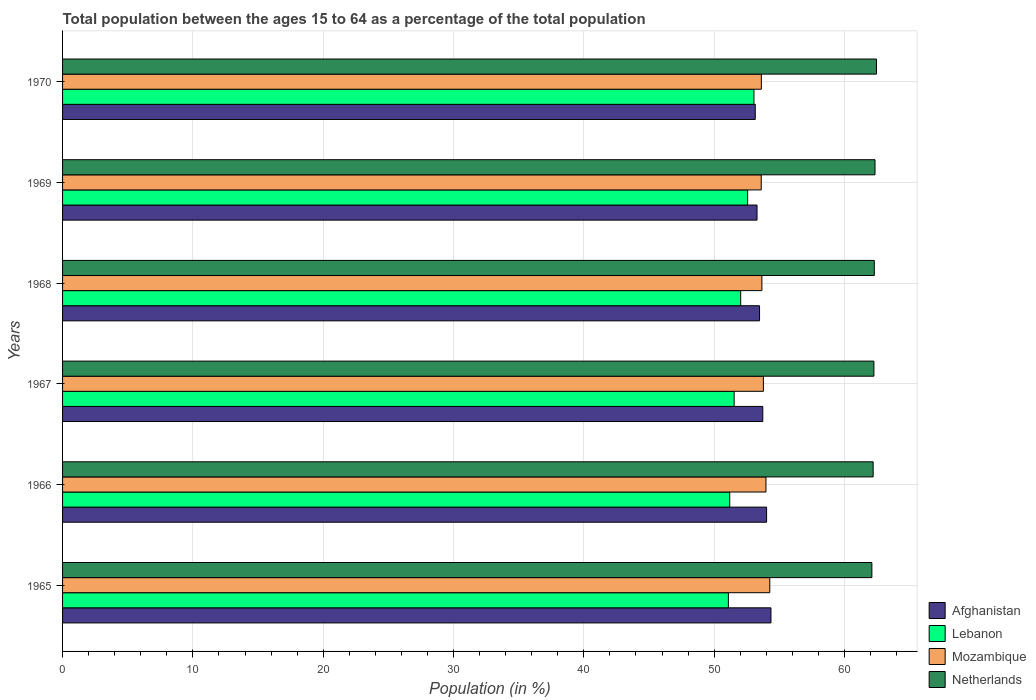How many different coloured bars are there?
Your answer should be very brief. 4. How many groups of bars are there?
Make the answer very short. 6. How many bars are there on the 3rd tick from the bottom?
Provide a short and direct response. 4. What is the label of the 1st group of bars from the top?
Provide a short and direct response. 1970. What is the percentage of the population ages 15 to 64 in Lebanon in 1965?
Give a very brief answer. 51.09. Across all years, what is the maximum percentage of the population ages 15 to 64 in Lebanon?
Provide a succinct answer. 53.06. Across all years, what is the minimum percentage of the population ages 15 to 64 in Mozambique?
Offer a terse response. 53.61. In which year was the percentage of the population ages 15 to 64 in Netherlands maximum?
Offer a terse response. 1970. In which year was the percentage of the population ages 15 to 64 in Lebanon minimum?
Provide a succinct answer. 1965. What is the total percentage of the population ages 15 to 64 in Mozambique in the graph?
Your response must be concise. 322.92. What is the difference between the percentage of the population ages 15 to 64 in Lebanon in 1966 and that in 1967?
Make the answer very short. -0.34. What is the difference between the percentage of the population ages 15 to 64 in Afghanistan in 1967 and the percentage of the population ages 15 to 64 in Netherlands in 1968?
Keep it short and to the point. -8.56. What is the average percentage of the population ages 15 to 64 in Lebanon per year?
Offer a very short reply. 51.91. In the year 1970, what is the difference between the percentage of the population ages 15 to 64 in Lebanon and percentage of the population ages 15 to 64 in Afghanistan?
Give a very brief answer. -0.1. What is the ratio of the percentage of the population ages 15 to 64 in Lebanon in 1969 to that in 1970?
Provide a short and direct response. 0.99. Is the percentage of the population ages 15 to 64 in Mozambique in 1966 less than that in 1967?
Keep it short and to the point. No. What is the difference between the highest and the second highest percentage of the population ages 15 to 64 in Afghanistan?
Your answer should be very brief. 0.33. What is the difference between the highest and the lowest percentage of the population ages 15 to 64 in Afghanistan?
Keep it short and to the point. 1.2. What does the 2nd bar from the top in 1969 represents?
Provide a short and direct response. Mozambique. What does the 1st bar from the bottom in 1968 represents?
Make the answer very short. Afghanistan. Is it the case that in every year, the sum of the percentage of the population ages 15 to 64 in Netherlands and percentage of the population ages 15 to 64 in Lebanon is greater than the percentage of the population ages 15 to 64 in Afghanistan?
Ensure brevity in your answer.  Yes. Does the graph contain any zero values?
Provide a short and direct response. No. Does the graph contain grids?
Keep it short and to the point. Yes. How many legend labels are there?
Keep it short and to the point. 4. How are the legend labels stacked?
Keep it short and to the point. Vertical. What is the title of the graph?
Provide a succinct answer. Total population between the ages 15 to 64 as a percentage of the total population. Does "Yemen, Rep." appear as one of the legend labels in the graph?
Your answer should be very brief. No. What is the label or title of the X-axis?
Ensure brevity in your answer.  Population (in %). What is the Population (in %) in Afghanistan in 1965?
Make the answer very short. 54.36. What is the Population (in %) in Lebanon in 1965?
Offer a very short reply. 51.09. What is the Population (in %) of Mozambique in 1965?
Provide a short and direct response. 54.27. What is the Population (in %) in Netherlands in 1965?
Your answer should be very brief. 62.1. What is the Population (in %) of Afghanistan in 1966?
Your answer should be compact. 54.03. What is the Population (in %) of Lebanon in 1966?
Your answer should be very brief. 51.2. What is the Population (in %) of Mozambique in 1966?
Make the answer very short. 53.98. What is the Population (in %) in Netherlands in 1966?
Give a very brief answer. 62.2. What is the Population (in %) in Afghanistan in 1967?
Your answer should be compact. 53.73. What is the Population (in %) of Lebanon in 1967?
Your answer should be very brief. 51.53. What is the Population (in %) of Mozambique in 1967?
Offer a very short reply. 53.78. What is the Population (in %) of Netherlands in 1967?
Provide a short and direct response. 62.26. What is the Population (in %) of Afghanistan in 1968?
Provide a short and direct response. 53.48. What is the Population (in %) of Lebanon in 1968?
Your response must be concise. 52.04. What is the Population (in %) in Mozambique in 1968?
Provide a succinct answer. 53.66. What is the Population (in %) of Netherlands in 1968?
Provide a short and direct response. 62.29. What is the Population (in %) of Afghanistan in 1969?
Your answer should be compact. 53.29. What is the Population (in %) of Lebanon in 1969?
Give a very brief answer. 52.57. What is the Population (in %) in Mozambique in 1969?
Give a very brief answer. 53.61. What is the Population (in %) of Netherlands in 1969?
Make the answer very short. 62.34. What is the Population (in %) in Afghanistan in 1970?
Your response must be concise. 53.16. What is the Population (in %) of Lebanon in 1970?
Ensure brevity in your answer.  53.06. What is the Population (in %) of Mozambique in 1970?
Your answer should be compact. 53.62. What is the Population (in %) of Netherlands in 1970?
Offer a very short reply. 62.45. Across all years, what is the maximum Population (in %) of Afghanistan?
Provide a short and direct response. 54.36. Across all years, what is the maximum Population (in %) of Lebanon?
Ensure brevity in your answer.  53.06. Across all years, what is the maximum Population (in %) of Mozambique?
Offer a very short reply. 54.27. Across all years, what is the maximum Population (in %) of Netherlands?
Provide a short and direct response. 62.45. Across all years, what is the minimum Population (in %) of Afghanistan?
Offer a very short reply. 53.16. Across all years, what is the minimum Population (in %) of Lebanon?
Give a very brief answer. 51.09. Across all years, what is the minimum Population (in %) of Mozambique?
Offer a terse response. 53.61. Across all years, what is the minimum Population (in %) in Netherlands?
Ensure brevity in your answer.  62.1. What is the total Population (in %) of Afghanistan in the graph?
Ensure brevity in your answer.  322.05. What is the total Population (in %) in Lebanon in the graph?
Your answer should be compact. 311.48. What is the total Population (in %) of Mozambique in the graph?
Provide a short and direct response. 322.92. What is the total Population (in %) in Netherlands in the graph?
Your answer should be compact. 373.65. What is the difference between the Population (in %) of Afghanistan in 1965 and that in 1966?
Your answer should be very brief. 0.33. What is the difference between the Population (in %) in Lebanon in 1965 and that in 1966?
Your answer should be compact. -0.1. What is the difference between the Population (in %) of Mozambique in 1965 and that in 1966?
Give a very brief answer. 0.29. What is the difference between the Population (in %) in Netherlands in 1965 and that in 1966?
Offer a terse response. -0.1. What is the difference between the Population (in %) in Afghanistan in 1965 and that in 1967?
Your answer should be compact. 0.63. What is the difference between the Population (in %) in Lebanon in 1965 and that in 1967?
Your response must be concise. -0.44. What is the difference between the Population (in %) of Mozambique in 1965 and that in 1967?
Make the answer very short. 0.49. What is the difference between the Population (in %) of Netherlands in 1965 and that in 1967?
Your answer should be very brief. -0.16. What is the difference between the Population (in %) in Afghanistan in 1965 and that in 1968?
Make the answer very short. 0.87. What is the difference between the Population (in %) in Lebanon in 1965 and that in 1968?
Keep it short and to the point. -0.94. What is the difference between the Population (in %) of Mozambique in 1965 and that in 1968?
Provide a short and direct response. 0.61. What is the difference between the Population (in %) in Netherlands in 1965 and that in 1968?
Offer a very short reply. -0.19. What is the difference between the Population (in %) in Afghanistan in 1965 and that in 1969?
Ensure brevity in your answer.  1.07. What is the difference between the Population (in %) of Lebanon in 1965 and that in 1969?
Give a very brief answer. -1.48. What is the difference between the Population (in %) of Mozambique in 1965 and that in 1969?
Provide a short and direct response. 0.66. What is the difference between the Population (in %) in Netherlands in 1965 and that in 1969?
Your response must be concise. -0.24. What is the difference between the Population (in %) in Afghanistan in 1965 and that in 1970?
Ensure brevity in your answer.  1.2. What is the difference between the Population (in %) of Lebanon in 1965 and that in 1970?
Your response must be concise. -1.96. What is the difference between the Population (in %) in Mozambique in 1965 and that in 1970?
Your answer should be very brief. 0.65. What is the difference between the Population (in %) in Netherlands in 1965 and that in 1970?
Provide a succinct answer. -0.35. What is the difference between the Population (in %) of Afghanistan in 1966 and that in 1967?
Your answer should be very brief. 0.29. What is the difference between the Population (in %) in Lebanon in 1966 and that in 1967?
Your answer should be very brief. -0.34. What is the difference between the Population (in %) of Mozambique in 1966 and that in 1967?
Provide a succinct answer. 0.2. What is the difference between the Population (in %) of Netherlands in 1966 and that in 1967?
Your answer should be compact. -0.06. What is the difference between the Population (in %) of Afghanistan in 1966 and that in 1968?
Give a very brief answer. 0.54. What is the difference between the Population (in %) in Lebanon in 1966 and that in 1968?
Keep it short and to the point. -0.84. What is the difference between the Population (in %) in Mozambique in 1966 and that in 1968?
Your response must be concise. 0.31. What is the difference between the Population (in %) in Netherlands in 1966 and that in 1968?
Give a very brief answer. -0.09. What is the difference between the Population (in %) of Afghanistan in 1966 and that in 1969?
Ensure brevity in your answer.  0.73. What is the difference between the Population (in %) of Lebanon in 1966 and that in 1969?
Keep it short and to the point. -1.37. What is the difference between the Population (in %) in Mozambique in 1966 and that in 1969?
Keep it short and to the point. 0.36. What is the difference between the Population (in %) of Netherlands in 1966 and that in 1969?
Ensure brevity in your answer.  -0.14. What is the difference between the Population (in %) in Afghanistan in 1966 and that in 1970?
Keep it short and to the point. 0.87. What is the difference between the Population (in %) in Lebanon in 1966 and that in 1970?
Keep it short and to the point. -1.86. What is the difference between the Population (in %) in Mozambique in 1966 and that in 1970?
Your response must be concise. 0.35. What is the difference between the Population (in %) of Netherlands in 1966 and that in 1970?
Offer a very short reply. -0.25. What is the difference between the Population (in %) of Afghanistan in 1967 and that in 1968?
Offer a very short reply. 0.25. What is the difference between the Population (in %) in Lebanon in 1967 and that in 1968?
Your response must be concise. -0.5. What is the difference between the Population (in %) of Mozambique in 1967 and that in 1968?
Offer a very short reply. 0.12. What is the difference between the Population (in %) of Netherlands in 1967 and that in 1968?
Make the answer very short. -0.03. What is the difference between the Population (in %) of Afghanistan in 1967 and that in 1969?
Offer a terse response. 0.44. What is the difference between the Population (in %) of Lebanon in 1967 and that in 1969?
Offer a terse response. -1.04. What is the difference between the Population (in %) of Mozambique in 1967 and that in 1969?
Make the answer very short. 0.17. What is the difference between the Population (in %) of Netherlands in 1967 and that in 1969?
Keep it short and to the point. -0.08. What is the difference between the Population (in %) in Afghanistan in 1967 and that in 1970?
Give a very brief answer. 0.58. What is the difference between the Population (in %) of Lebanon in 1967 and that in 1970?
Offer a very short reply. -1.52. What is the difference between the Population (in %) in Mozambique in 1967 and that in 1970?
Offer a terse response. 0.16. What is the difference between the Population (in %) of Netherlands in 1967 and that in 1970?
Provide a succinct answer. -0.2. What is the difference between the Population (in %) of Afghanistan in 1968 and that in 1969?
Give a very brief answer. 0.19. What is the difference between the Population (in %) of Lebanon in 1968 and that in 1969?
Offer a terse response. -0.53. What is the difference between the Population (in %) of Mozambique in 1968 and that in 1969?
Your answer should be very brief. 0.05. What is the difference between the Population (in %) of Netherlands in 1968 and that in 1969?
Provide a short and direct response. -0.06. What is the difference between the Population (in %) of Afghanistan in 1968 and that in 1970?
Your answer should be compact. 0.33. What is the difference between the Population (in %) of Lebanon in 1968 and that in 1970?
Your response must be concise. -1.02. What is the difference between the Population (in %) of Mozambique in 1968 and that in 1970?
Give a very brief answer. 0.04. What is the difference between the Population (in %) in Netherlands in 1968 and that in 1970?
Provide a short and direct response. -0.17. What is the difference between the Population (in %) of Afghanistan in 1969 and that in 1970?
Your answer should be compact. 0.14. What is the difference between the Population (in %) of Lebanon in 1969 and that in 1970?
Provide a succinct answer. -0.48. What is the difference between the Population (in %) in Mozambique in 1969 and that in 1970?
Provide a short and direct response. -0.01. What is the difference between the Population (in %) in Netherlands in 1969 and that in 1970?
Give a very brief answer. -0.11. What is the difference between the Population (in %) in Afghanistan in 1965 and the Population (in %) in Lebanon in 1966?
Ensure brevity in your answer.  3.16. What is the difference between the Population (in %) of Afghanistan in 1965 and the Population (in %) of Mozambique in 1966?
Provide a short and direct response. 0.38. What is the difference between the Population (in %) in Afghanistan in 1965 and the Population (in %) in Netherlands in 1966?
Offer a very short reply. -7.84. What is the difference between the Population (in %) in Lebanon in 1965 and the Population (in %) in Mozambique in 1966?
Offer a terse response. -2.88. What is the difference between the Population (in %) of Lebanon in 1965 and the Population (in %) of Netherlands in 1966?
Provide a succinct answer. -11.11. What is the difference between the Population (in %) in Mozambique in 1965 and the Population (in %) in Netherlands in 1966?
Provide a short and direct response. -7.93. What is the difference between the Population (in %) in Afghanistan in 1965 and the Population (in %) in Lebanon in 1967?
Your response must be concise. 2.82. What is the difference between the Population (in %) of Afghanistan in 1965 and the Population (in %) of Mozambique in 1967?
Your answer should be very brief. 0.58. What is the difference between the Population (in %) of Afghanistan in 1965 and the Population (in %) of Netherlands in 1967?
Keep it short and to the point. -7.9. What is the difference between the Population (in %) in Lebanon in 1965 and the Population (in %) in Mozambique in 1967?
Offer a very short reply. -2.69. What is the difference between the Population (in %) of Lebanon in 1965 and the Population (in %) of Netherlands in 1967?
Provide a short and direct response. -11.17. What is the difference between the Population (in %) in Mozambique in 1965 and the Population (in %) in Netherlands in 1967?
Your response must be concise. -7.99. What is the difference between the Population (in %) in Afghanistan in 1965 and the Population (in %) in Lebanon in 1968?
Your answer should be very brief. 2.32. What is the difference between the Population (in %) in Afghanistan in 1965 and the Population (in %) in Mozambique in 1968?
Your answer should be compact. 0.7. What is the difference between the Population (in %) of Afghanistan in 1965 and the Population (in %) of Netherlands in 1968?
Offer a very short reply. -7.93. What is the difference between the Population (in %) of Lebanon in 1965 and the Population (in %) of Mozambique in 1968?
Ensure brevity in your answer.  -2.57. What is the difference between the Population (in %) in Lebanon in 1965 and the Population (in %) in Netherlands in 1968?
Offer a terse response. -11.2. What is the difference between the Population (in %) of Mozambique in 1965 and the Population (in %) of Netherlands in 1968?
Provide a succinct answer. -8.02. What is the difference between the Population (in %) of Afghanistan in 1965 and the Population (in %) of Lebanon in 1969?
Your response must be concise. 1.79. What is the difference between the Population (in %) of Afghanistan in 1965 and the Population (in %) of Mozambique in 1969?
Keep it short and to the point. 0.75. What is the difference between the Population (in %) of Afghanistan in 1965 and the Population (in %) of Netherlands in 1969?
Provide a short and direct response. -7.99. What is the difference between the Population (in %) in Lebanon in 1965 and the Population (in %) in Mozambique in 1969?
Provide a short and direct response. -2.52. What is the difference between the Population (in %) of Lebanon in 1965 and the Population (in %) of Netherlands in 1969?
Offer a very short reply. -11.25. What is the difference between the Population (in %) of Mozambique in 1965 and the Population (in %) of Netherlands in 1969?
Ensure brevity in your answer.  -8.07. What is the difference between the Population (in %) of Afghanistan in 1965 and the Population (in %) of Lebanon in 1970?
Keep it short and to the point. 1.3. What is the difference between the Population (in %) of Afghanistan in 1965 and the Population (in %) of Mozambique in 1970?
Offer a terse response. 0.73. What is the difference between the Population (in %) of Afghanistan in 1965 and the Population (in %) of Netherlands in 1970?
Your answer should be compact. -8.1. What is the difference between the Population (in %) in Lebanon in 1965 and the Population (in %) in Mozambique in 1970?
Ensure brevity in your answer.  -2.53. What is the difference between the Population (in %) of Lebanon in 1965 and the Population (in %) of Netherlands in 1970?
Provide a succinct answer. -11.36. What is the difference between the Population (in %) in Mozambique in 1965 and the Population (in %) in Netherlands in 1970?
Your response must be concise. -8.19. What is the difference between the Population (in %) in Afghanistan in 1966 and the Population (in %) in Lebanon in 1967?
Make the answer very short. 2.49. What is the difference between the Population (in %) of Afghanistan in 1966 and the Population (in %) of Mozambique in 1967?
Offer a terse response. 0.25. What is the difference between the Population (in %) of Afghanistan in 1966 and the Population (in %) of Netherlands in 1967?
Offer a terse response. -8.23. What is the difference between the Population (in %) in Lebanon in 1966 and the Population (in %) in Mozambique in 1967?
Give a very brief answer. -2.58. What is the difference between the Population (in %) of Lebanon in 1966 and the Population (in %) of Netherlands in 1967?
Offer a very short reply. -11.06. What is the difference between the Population (in %) of Mozambique in 1966 and the Population (in %) of Netherlands in 1967?
Offer a terse response. -8.28. What is the difference between the Population (in %) in Afghanistan in 1966 and the Population (in %) in Lebanon in 1968?
Provide a short and direct response. 1.99. What is the difference between the Population (in %) in Afghanistan in 1966 and the Population (in %) in Mozambique in 1968?
Make the answer very short. 0.36. What is the difference between the Population (in %) of Afghanistan in 1966 and the Population (in %) of Netherlands in 1968?
Give a very brief answer. -8.26. What is the difference between the Population (in %) in Lebanon in 1966 and the Population (in %) in Mozambique in 1968?
Your answer should be very brief. -2.47. What is the difference between the Population (in %) of Lebanon in 1966 and the Population (in %) of Netherlands in 1968?
Your answer should be compact. -11.09. What is the difference between the Population (in %) of Mozambique in 1966 and the Population (in %) of Netherlands in 1968?
Offer a terse response. -8.31. What is the difference between the Population (in %) of Afghanistan in 1966 and the Population (in %) of Lebanon in 1969?
Provide a short and direct response. 1.45. What is the difference between the Population (in %) of Afghanistan in 1966 and the Population (in %) of Mozambique in 1969?
Keep it short and to the point. 0.41. What is the difference between the Population (in %) of Afghanistan in 1966 and the Population (in %) of Netherlands in 1969?
Your response must be concise. -8.32. What is the difference between the Population (in %) of Lebanon in 1966 and the Population (in %) of Mozambique in 1969?
Your answer should be compact. -2.42. What is the difference between the Population (in %) in Lebanon in 1966 and the Population (in %) in Netherlands in 1969?
Provide a short and direct response. -11.15. What is the difference between the Population (in %) in Mozambique in 1966 and the Population (in %) in Netherlands in 1969?
Provide a succinct answer. -8.37. What is the difference between the Population (in %) of Afghanistan in 1966 and the Population (in %) of Lebanon in 1970?
Your answer should be very brief. 0.97. What is the difference between the Population (in %) of Afghanistan in 1966 and the Population (in %) of Mozambique in 1970?
Keep it short and to the point. 0.4. What is the difference between the Population (in %) of Afghanistan in 1966 and the Population (in %) of Netherlands in 1970?
Make the answer very short. -8.43. What is the difference between the Population (in %) in Lebanon in 1966 and the Population (in %) in Mozambique in 1970?
Give a very brief answer. -2.43. What is the difference between the Population (in %) in Lebanon in 1966 and the Population (in %) in Netherlands in 1970?
Your answer should be compact. -11.26. What is the difference between the Population (in %) in Mozambique in 1966 and the Population (in %) in Netherlands in 1970?
Your response must be concise. -8.48. What is the difference between the Population (in %) in Afghanistan in 1967 and the Population (in %) in Lebanon in 1968?
Offer a terse response. 1.7. What is the difference between the Population (in %) of Afghanistan in 1967 and the Population (in %) of Mozambique in 1968?
Your response must be concise. 0.07. What is the difference between the Population (in %) of Afghanistan in 1967 and the Population (in %) of Netherlands in 1968?
Your answer should be very brief. -8.56. What is the difference between the Population (in %) of Lebanon in 1967 and the Population (in %) of Mozambique in 1968?
Make the answer very short. -2.13. What is the difference between the Population (in %) of Lebanon in 1967 and the Population (in %) of Netherlands in 1968?
Your response must be concise. -10.75. What is the difference between the Population (in %) in Mozambique in 1967 and the Population (in %) in Netherlands in 1968?
Provide a succinct answer. -8.51. What is the difference between the Population (in %) of Afghanistan in 1967 and the Population (in %) of Lebanon in 1969?
Keep it short and to the point. 1.16. What is the difference between the Population (in %) in Afghanistan in 1967 and the Population (in %) in Mozambique in 1969?
Your answer should be very brief. 0.12. What is the difference between the Population (in %) of Afghanistan in 1967 and the Population (in %) of Netherlands in 1969?
Make the answer very short. -8.61. What is the difference between the Population (in %) in Lebanon in 1967 and the Population (in %) in Mozambique in 1969?
Your answer should be compact. -2.08. What is the difference between the Population (in %) of Lebanon in 1967 and the Population (in %) of Netherlands in 1969?
Provide a short and direct response. -10.81. What is the difference between the Population (in %) of Mozambique in 1967 and the Population (in %) of Netherlands in 1969?
Provide a short and direct response. -8.56. What is the difference between the Population (in %) in Afghanistan in 1967 and the Population (in %) in Lebanon in 1970?
Keep it short and to the point. 0.68. What is the difference between the Population (in %) of Afghanistan in 1967 and the Population (in %) of Mozambique in 1970?
Offer a terse response. 0.11. What is the difference between the Population (in %) of Afghanistan in 1967 and the Population (in %) of Netherlands in 1970?
Give a very brief answer. -8.72. What is the difference between the Population (in %) of Lebanon in 1967 and the Population (in %) of Mozambique in 1970?
Offer a very short reply. -2.09. What is the difference between the Population (in %) in Lebanon in 1967 and the Population (in %) in Netherlands in 1970?
Your response must be concise. -10.92. What is the difference between the Population (in %) of Mozambique in 1967 and the Population (in %) of Netherlands in 1970?
Keep it short and to the point. -8.68. What is the difference between the Population (in %) in Afghanistan in 1968 and the Population (in %) in Lebanon in 1969?
Make the answer very short. 0.91. What is the difference between the Population (in %) of Afghanistan in 1968 and the Population (in %) of Mozambique in 1969?
Your answer should be compact. -0.13. What is the difference between the Population (in %) in Afghanistan in 1968 and the Population (in %) in Netherlands in 1969?
Your answer should be very brief. -8.86. What is the difference between the Population (in %) in Lebanon in 1968 and the Population (in %) in Mozambique in 1969?
Keep it short and to the point. -1.58. What is the difference between the Population (in %) in Lebanon in 1968 and the Population (in %) in Netherlands in 1969?
Provide a succinct answer. -10.31. What is the difference between the Population (in %) of Mozambique in 1968 and the Population (in %) of Netherlands in 1969?
Ensure brevity in your answer.  -8.68. What is the difference between the Population (in %) in Afghanistan in 1968 and the Population (in %) in Lebanon in 1970?
Make the answer very short. 0.43. What is the difference between the Population (in %) in Afghanistan in 1968 and the Population (in %) in Mozambique in 1970?
Offer a terse response. -0.14. What is the difference between the Population (in %) of Afghanistan in 1968 and the Population (in %) of Netherlands in 1970?
Keep it short and to the point. -8.97. What is the difference between the Population (in %) in Lebanon in 1968 and the Population (in %) in Mozambique in 1970?
Ensure brevity in your answer.  -1.59. What is the difference between the Population (in %) of Lebanon in 1968 and the Population (in %) of Netherlands in 1970?
Your answer should be compact. -10.42. What is the difference between the Population (in %) in Mozambique in 1968 and the Population (in %) in Netherlands in 1970?
Make the answer very short. -8.79. What is the difference between the Population (in %) in Afghanistan in 1969 and the Population (in %) in Lebanon in 1970?
Your answer should be very brief. 0.24. What is the difference between the Population (in %) of Afghanistan in 1969 and the Population (in %) of Mozambique in 1970?
Your response must be concise. -0.33. What is the difference between the Population (in %) in Afghanistan in 1969 and the Population (in %) in Netherlands in 1970?
Keep it short and to the point. -9.16. What is the difference between the Population (in %) of Lebanon in 1969 and the Population (in %) of Mozambique in 1970?
Give a very brief answer. -1.05. What is the difference between the Population (in %) of Lebanon in 1969 and the Population (in %) of Netherlands in 1970?
Ensure brevity in your answer.  -9.88. What is the difference between the Population (in %) of Mozambique in 1969 and the Population (in %) of Netherlands in 1970?
Give a very brief answer. -8.84. What is the average Population (in %) of Afghanistan per year?
Your response must be concise. 53.67. What is the average Population (in %) of Lebanon per year?
Your answer should be very brief. 51.91. What is the average Population (in %) of Mozambique per year?
Offer a very short reply. 53.82. What is the average Population (in %) of Netherlands per year?
Keep it short and to the point. 62.28. In the year 1965, what is the difference between the Population (in %) in Afghanistan and Population (in %) in Lebanon?
Your response must be concise. 3.27. In the year 1965, what is the difference between the Population (in %) in Afghanistan and Population (in %) in Mozambique?
Your response must be concise. 0.09. In the year 1965, what is the difference between the Population (in %) of Afghanistan and Population (in %) of Netherlands?
Provide a succinct answer. -7.74. In the year 1965, what is the difference between the Population (in %) of Lebanon and Population (in %) of Mozambique?
Make the answer very short. -3.18. In the year 1965, what is the difference between the Population (in %) of Lebanon and Population (in %) of Netherlands?
Ensure brevity in your answer.  -11.01. In the year 1965, what is the difference between the Population (in %) of Mozambique and Population (in %) of Netherlands?
Ensure brevity in your answer.  -7.83. In the year 1966, what is the difference between the Population (in %) of Afghanistan and Population (in %) of Lebanon?
Your response must be concise. 2.83. In the year 1966, what is the difference between the Population (in %) in Afghanistan and Population (in %) in Mozambique?
Provide a succinct answer. 0.05. In the year 1966, what is the difference between the Population (in %) in Afghanistan and Population (in %) in Netherlands?
Give a very brief answer. -8.18. In the year 1966, what is the difference between the Population (in %) of Lebanon and Population (in %) of Mozambique?
Offer a very short reply. -2.78. In the year 1966, what is the difference between the Population (in %) of Lebanon and Population (in %) of Netherlands?
Your response must be concise. -11.01. In the year 1966, what is the difference between the Population (in %) in Mozambique and Population (in %) in Netherlands?
Your response must be concise. -8.23. In the year 1967, what is the difference between the Population (in %) in Afghanistan and Population (in %) in Lebanon?
Keep it short and to the point. 2.2. In the year 1967, what is the difference between the Population (in %) of Afghanistan and Population (in %) of Mozambique?
Ensure brevity in your answer.  -0.05. In the year 1967, what is the difference between the Population (in %) in Afghanistan and Population (in %) in Netherlands?
Offer a terse response. -8.53. In the year 1967, what is the difference between the Population (in %) in Lebanon and Population (in %) in Mozambique?
Keep it short and to the point. -2.25. In the year 1967, what is the difference between the Population (in %) in Lebanon and Population (in %) in Netherlands?
Offer a very short reply. -10.72. In the year 1967, what is the difference between the Population (in %) in Mozambique and Population (in %) in Netherlands?
Give a very brief answer. -8.48. In the year 1968, what is the difference between the Population (in %) of Afghanistan and Population (in %) of Lebanon?
Keep it short and to the point. 1.45. In the year 1968, what is the difference between the Population (in %) of Afghanistan and Population (in %) of Mozambique?
Your answer should be compact. -0.18. In the year 1968, what is the difference between the Population (in %) of Afghanistan and Population (in %) of Netherlands?
Ensure brevity in your answer.  -8.8. In the year 1968, what is the difference between the Population (in %) in Lebanon and Population (in %) in Mozambique?
Keep it short and to the point. -1.63. In the year 1968, what is the difference between the Population (in %) of Lebanon and Population (in %) of Netherlands?
Make the answer very short. -10.25. In the year 1968, what is the difference between the Population (in %) in Mozambique and Population (in %) in Netherlands?
Your answer should be compact. -8.63. In the year 1969, what is the difference between the Population (in %) in Afghanistan and Population (in %) in Lebanon?
Provide a short and direct response. 0.72. In the year 1969, what is the difference between the Population (in %) in Afghanistan and Population (in %) in Mozambique?
Your response must be concise. -0.32. In the year 1969, what is the difference between the Population (in %) of Afghanistan and Population (in %) of Netherlands?
Give a very brief answer. -9.05. In the year 1969, what is the difference between the Population (in %) in Lebanon and Population (in %) in Mozambique?
Provide a succinct answer. -1.04. In the year 1969, what is the difference between the Population (in %) in Lebanon and Population (in %) in Netherlands?
Your answer should be very brief. -9.77. In the year 1969, what is the difference between the Population (in %) in Mozambique and Population (in %) in Netherlands?
Offer a terse response. -8.73. In the year 1970, what is the difference between the Population (in %) of Afghanistan and Population (in %) of Lebanon?
Your answer should be compact. 0.1. In the year 1970, what is the difference between the Population (in %) in Afghanistan and Population (in %) in Mozambique?
Your response must be concise. -0.47. In the year 1970, what is the difference between the Population (in %) of Afghanistan and Population (in %) of Netherlands?
Offer a very short reply. -9.3. In the year 1970, what is the difference between the Population (in %) in Lebanon and Population (in %) in Mozambique?
Provide a succinct answer. -0.57. In the year 1970, what is the difference between the Population (in %) of Lebanon and Population (in %) of Netherlands?
Give a very brief answer. -9.4. In the year 1970, what is the difference between the Population (in %) of Mozambique and Population (in %) of Netherlands?
Ensure brevity in your answer.  -8.83. What is the ratio of the Population (in %) in Afghanistan in 1965 to that in 1966?
Your response must be concise. 1.01. What is the ratio of the Population (in %) in Lebanon in 1965 to that in 1966?
Offer a terse response. 1. What is the ratio of the Population (in %) of Mozambique in 1965 to that in 1966?
Provide a short and direct response. 1.01. What is the ratio of the Population (in %) of Afghanistan in 1965 to that in 1967?
Offer a very short reply. 1.01. What is the ratio of the Population (in %) in Mozambique in 1965 to that in 1967?
Provide a succinct answer. 1.01. What is the ratio of the Population (in %) of Netherlands in 1965 to that in 1967?
Provide a succinct answer. 1. What is the ratio of the Population (in %) of Afghanistan in 1965 to that in 1968?
Keep it short and to the point. 1.02. What is the ratio of the Population (in %) of Lebanon in 1965 to that in 1968?
Offer a terse response. 0.98. What is the ratio of the Population (in %) of Mozambique in 1965 to that in 1968?
Give a very brief answer. 1.01. What is the ratio of the Population (in %) in Netherlands in 1965 to that in 1968?
Keep it short and to the point. 1. What is the ratio of the Population (in %) in Afghanistan in 1965 to that in 1969?
Offer a very short reply. 1.02. What is the ratio of the Population (in %) of Lebanon in 1965 to that in 1969?
Keep it short and to the point. 0.97. What is the ratio of the Population (in %) in Mozambique in 1965 to that in 1969?
Ensure brevity in your answer.  1.01. What is the ratio of the Population (in %) in Netherlands in 1965 to that in 1969?
Ensure brevity in your answer.  1. What is the ratio of the Population (in %) of Afghanistan in 1965 to that in 1970?
Your response must be concise. 1.02. What is the ratio of the Population (in %) of Mozambique in 1965 to that in 1970?
Provide a succinct answer. 1.01. What is the ratio of the Population (in %) of Afghanistan in 1966 to that in 1967?
Ensure brevity in your answer.  1.01. What is the ratio of the Population (in %) of Afghanistan in 1966 to that in 1968?
Ensure brevity in your answer.  1.01. What is the ratio of the Population (in %) in Lebanon in 1966 to that in 1968?
Your response must be concise. 0.98. What is the ratio of the Population (in %) of Mozambique in 1966 to that in 1968?
Make the answer very short. 1.01. What is the ratio of the Population (in %) in Netherlands in 1966 to that in 1968?
Your answer should be very brief. 1. What is the ratio of the Population (in %) of Afghanistan in 1966 to that in 1969?
Ensure brevity in your answer.  1.01. What is the ratio of the Population (in %) in Lebanon in 1966 to that in 1969?
Make the answer very short. 0.97. What is the ratio of the Population (in %) of Mozambique in 1966 to that in 1969?
Make the answer very short. 1.01. What is the ratio of the Population (in %) in Netherlands in 1966 to that in 1969?
Offer a terse response. 1. What is the ratio of the Population (in %) in Afghanistan in 1966 to that in 1970?
Provide a succinct answer. 1.02. What is the ratio of the Population (in %) of Lebanon in 1966 to that in 1970?
Offer a terse response. 0.96. What is the ratio of the Population (in %) in Mozambique in 1966 to that in 1970?
Offer a very short reply. 1.01. What is the ratio of the Population (in %) of Lebanon in 1967 to that in 1968?
Your response must be concise. 0.99. What is the ratio of the Population (in %) of Netherlands in 1967 to that in 1968?
Ensure brevity in your answer.  1. What is the ratio of the Population (in %) in Afghanistan in 1967 to that in 1969?
Offer a very short reply. 1.01. What is the ratio of the Population (in %) of Lebanon in 1967 to that in 1969?
Make the answer very short. 0.98. What is the ratio of the Population (in %) in Afghanistan in 1967 to that in 1970?
Your answer should be very brief. 1.01. What is the ratio of the Population (in %) in Lebanon in 1967 to that in 1970?
Your response must be concise. 0.97. What is the ratio of the Population (in %) in Mozambique in 1967 to that in 1970?
Your answer should be very brief. 1. What is the ratio of the Population (in %) in Netherlands in 1967 to that in 1970?
Offer a very short reply. 1. What is the ratio of the Population (in %) in Lebanon in 1968 to that in 1969?
Offer a very short reply. 0.99. What is the ratio of the Population (in %) of Mozambique in 1968 to that in 1969?
Keep it short and to the point. 1. What is the ratio of the Population (in %) in Lebanon in 1968 to that in 1970?
Offer a terse response. 0.98. What is the ratio of the Population (in %) in Afghanistan in 1969 to that in 1970?
Make the answer very short. 1. What is the ratio of the Population (in %) in Lebanon in 1969 to that in 1970?
Keep it short and to the point. 0.99. What is the ratio of the Population (in %) in Mozambique in 1969 to that in 1970?
Your response must be concise. 1. What is the difference between the highest and the second highest Population (in %) of Afghanistan?
Keep it short and to the point. 0.33. What is the difference between the highest and the second highest Population (in %) of Lebanon?
Ensure brevity in your answer.  0.48. What is the difference between the highest and the second highest Population (in %) of Mozambique?
Provide a short and direct response. 0.29. What is the difference between the highest and the second highest Population (in %) in Netherlands?
Give a very brief answer. 0.11. What is the difference between the highest and the lowest Population (in %) of Afghanistan?
Make the answer very short. 1.2. What is the difference between the highest and the lowest Population (in %) of Lebanon?
Make the answer very short. 1.96. What is the difference between the highest and the lowest Population (in %) of Mozambique?
Provide a short and direct response. 0.66. What is the difference between the highest and the lowest Population (in %) in Netherlands?
Provide a succinct answer. 0.35. 